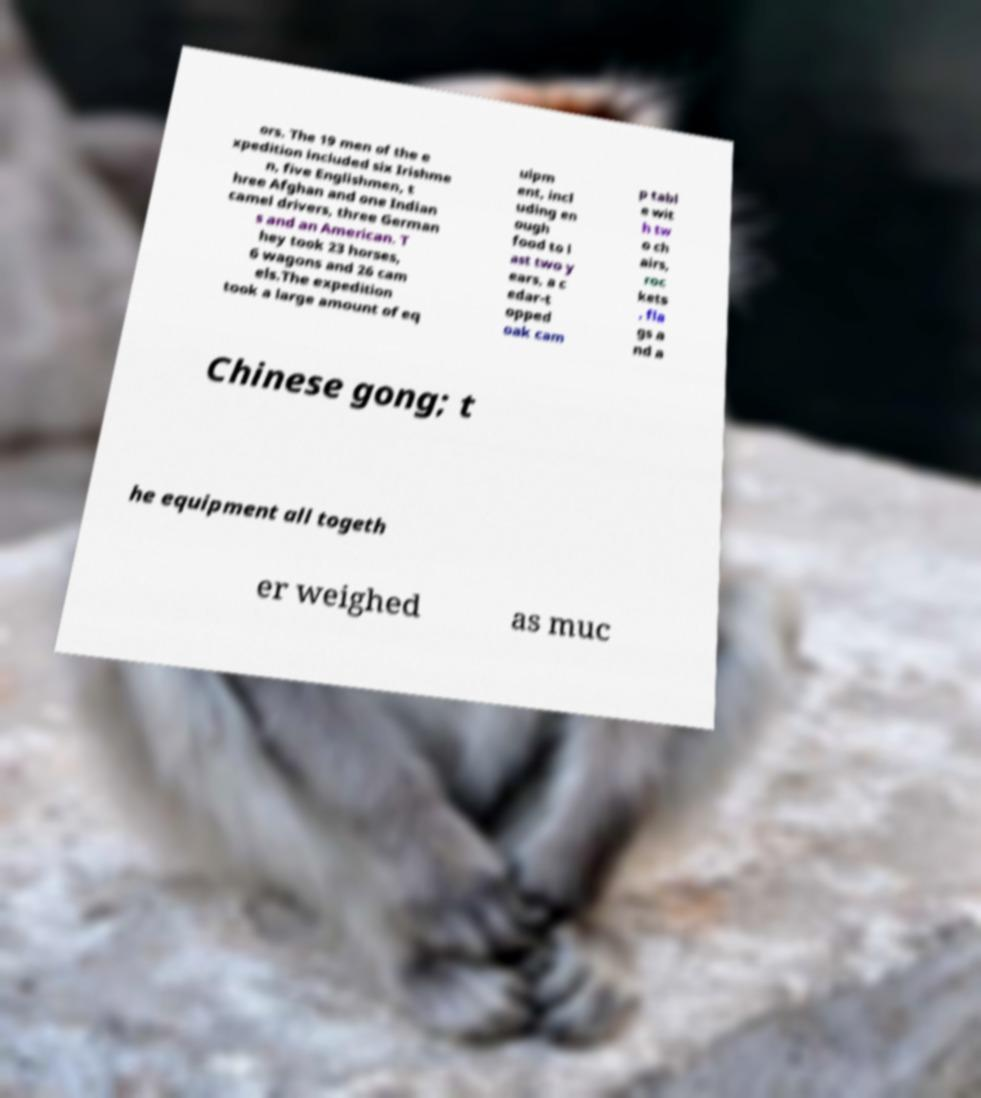There's text embedded in this image that I need extracted. Can you transcribe it verbatim? ors. The 19 men of the e xpedition included six Irishme n, five Englishmen, t hree Afghan and one Indian camel drivers, three German s and an American. T hey took 23 horses, 6 wagons and 26 cam els.The expedition took a large amount of eq uipm ent, incl uding en ough food to l ast two y ears, a c edar-t opped oak cam p tabl e wit h tw o ch airs, roc kets , fla gs a nd a Chinese gong; t he equipment all togeth er weighed as muc 